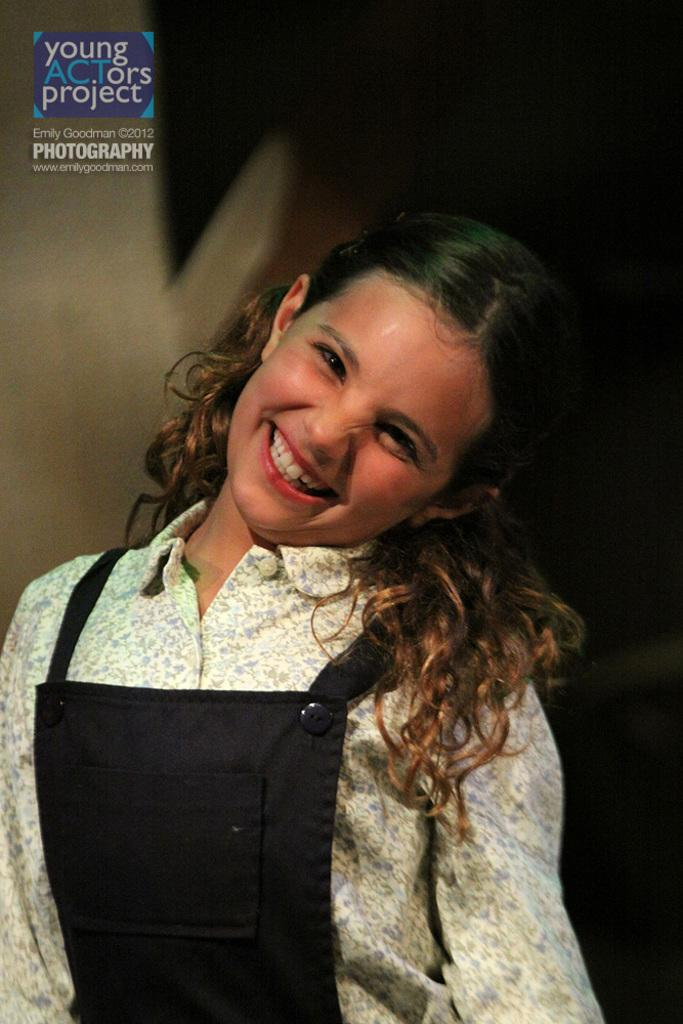What is the main subject in the foreground of the image? There is a person in the foreground of the image. What can be observed about the background of the image? The background of the image is blurred. How many children are playing with the duck in the image? There is no duck or children present in the image. What decision is the person making in the image? The provided facts do not mention any decision being made by the person in the image. 